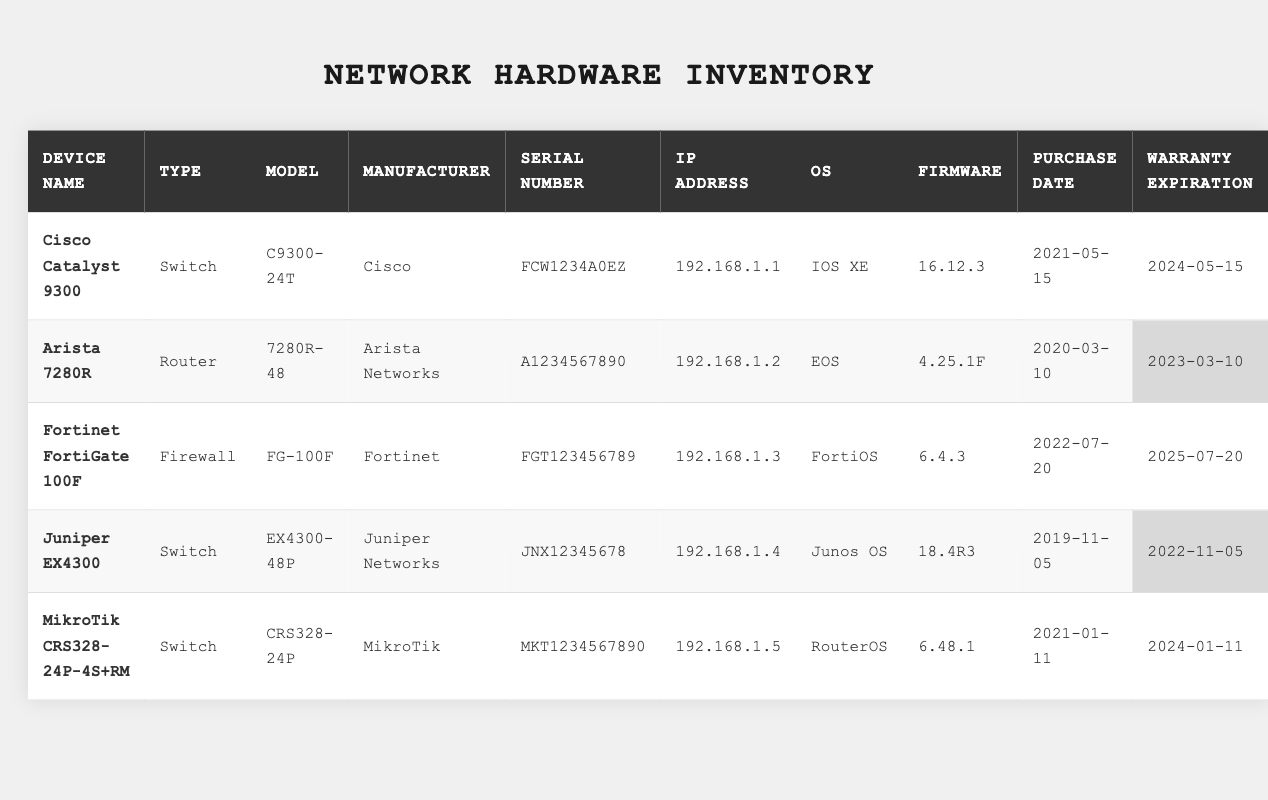What is the IP address of the Fortinet FortiGate 100F? The table shows that the IP address for the Fortinet FortiGate 100F device is listed in the "IP Address" column. Upon reviewing the row, it is found to be 192.168.1.3.
Answer: 192.168.1.3 Which device has the warranty expiring soonest? To determine which device has the earliest warranty expiration, I need to review the "Warranty Expiration" column and identify the date that is the earliest. The dates listed are 2024-05-15, 2023-03-10, 2025-07-20, 2022-11-05, and 2024-01-11. The earliest date is 2023-03-10 for the Arista 7280R.
Answer: Arista 7280R How many switches are listed in the inventory? I will count the number of devices in the table and focus on the "Device Type" column, only counting those labeled as "Switch". The devices that match this type in the table are the Cisco Catalyst 9300, Juniper EX4300, and MikroTik CRS328-24P-4S+RM, which totals to three devices.
Answer: 3 Is the firmware version of the Cisco Catalyst 9300 greater than the firmware version of the Juniper EX4300? I will compare the "Firmware" column for both devices. The Cisco Catalyst 9300 has a firmware version of 16.12.3, while the Juniper EX4300 shows 18.4R3. By comparing these two, I can see that 18.4R3 is greater than 16.12.3.
Answer: Yes What is the average warranty duration for all devices in the inventory? First, I'll calculate the warranty duration for each device based on the purchase date and warranty expiration. For example, the Cisco Catalyst 9300 has a warranty duration of 3 years, Arista 7280R is 3 years, Fortinet FortiGate 100F is 3 years, Juniper EX4300 is 3 years, and MikroTik CRS328-24P-4S+RM is 3 years. Adding these gives me 3 + 3 + 3 + 3 + 3 = 15 years. Next, I divide by the number of devices (5) to find the average: 15 / 5 = 3.
Answer: 3 years Which manufacturer has the most devices listed in the inventory? I will review the "Manufacturer" column and tally the occurrences for each. The results show that Cisco has 1 device, Arista Networks has 1, Fortinet has 1, Juniper Networks has 1, and MikroTik has 1. Since all manufacturers have only 1 device, there is no single manufacturer with the most devices.
Answer: None What is the operating system for the device with serial number JNX12345678? To find the operating system, I will locate the row of the device with the given serial number in the "Serial Number" column. The device with serial number JNX12345678 is the Juniper EX4300, and its operating system is listed as "Junos OS".
Answer: Junos OS If I want to purchase another device from Cisco, what model should I choose based on this table? Looking at the "Manufacturer" column, Cisco is represented by the Cisco Catalyst 9300 with model number C9300-24T. Therefore, the model I should consider purchasing from Cisco is C9300-24T, as it is the only one listed in the table.
Answer: C9300-24T 